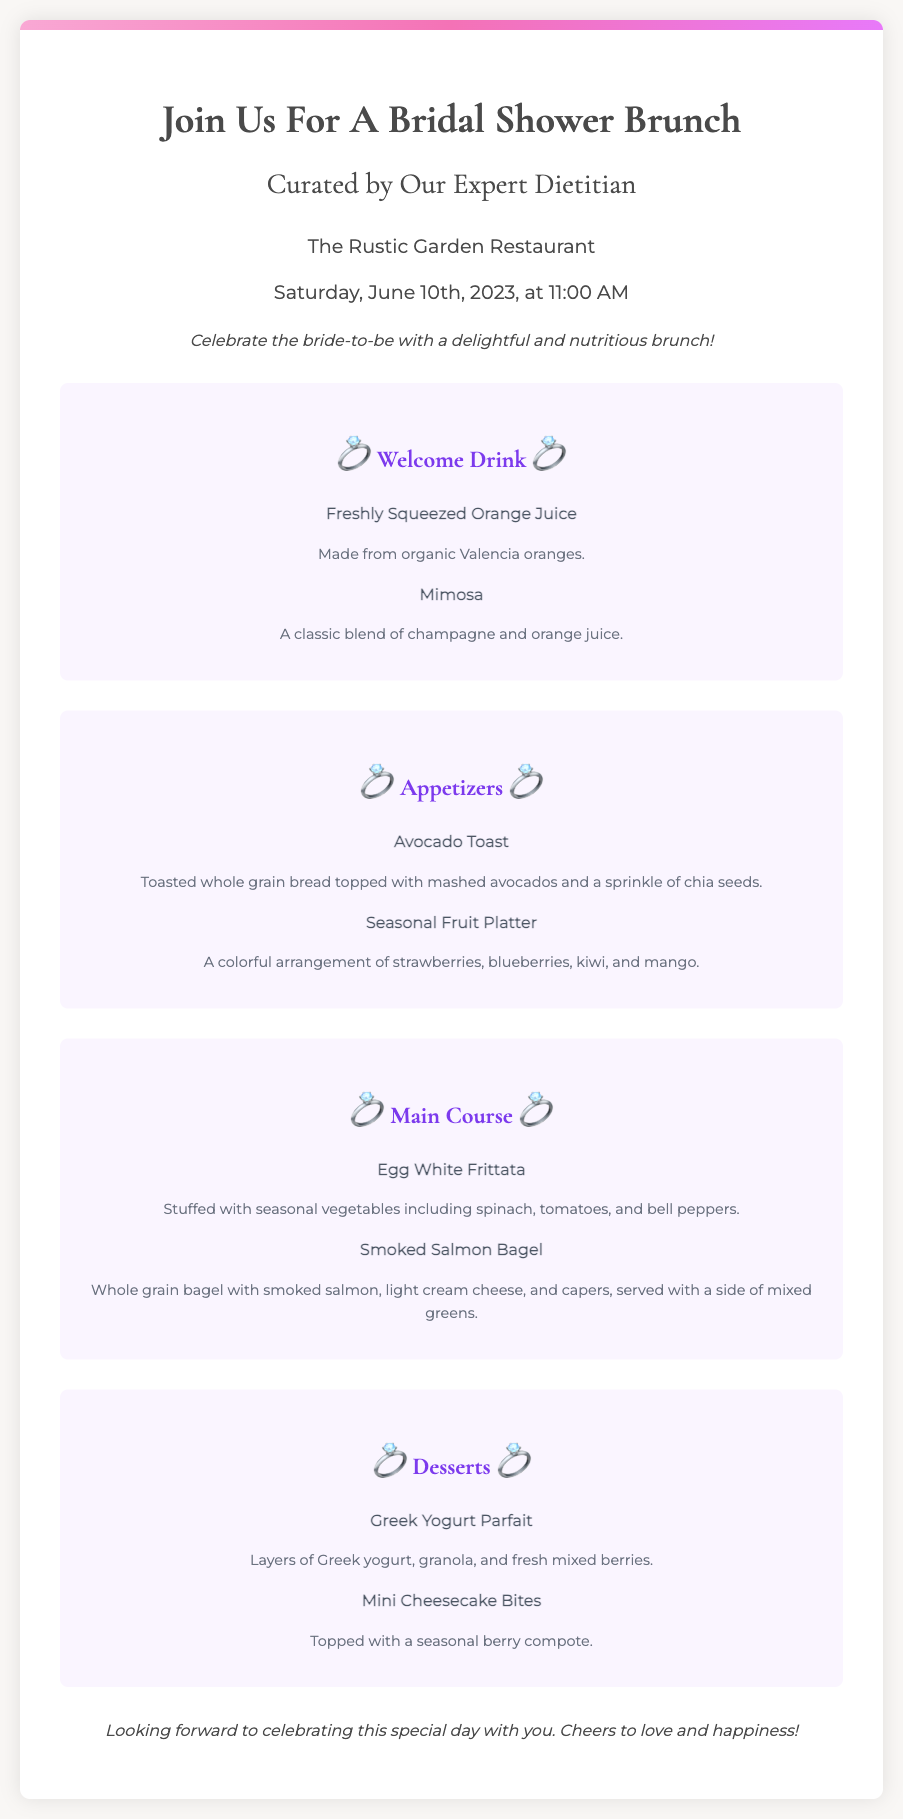What is the date of the Bridal Shower Brunch? The date is explicitly mentioned in the document as "Saturday, June 10th, 2023."
Answer: Saturday, June 10th, 2023 What is the time of the event? The time is provided within the date-time section of the document, stating "at 11:00 AM."
Answer: 11:00 AM Who curated the menu for the brunch? It is specified in the title that the menu is "Curated by Our Expert Dietitian."
Answer: Our Expert Dietitian What is one of the welcome drinks listed? The document lists specific welcome drinks, including "Freshly Squeezed Orange Juice."
Answer: Freshly Squeezed Orange Juice What type of bread is used for the Avocado Toast? The description of the Avocado Toast states it is made with "toasted whole grain bread."
Answer: Whole grain bread How many menu sections are there in the document? The document outlines the menu in four distinct sections: Welcome Drink, Appetizers, Main Course, and Desserts.
Answer: Four What is included in the Seasonal Fruit Platter? The platter is described to contain "strawberries, blueberries, kiwi, and mango."
Answer: Strawberries, blueberries, kiwi, and mango What dessert features Greek yogurt? The Greek Yogurt Parfait is mentioned under the desserts section in the document.
Answer: Greek Yogurt Parfait What does the closing statement express? The closing expresses anticipation and positivity about the event, stating, "Looking forward to celebrating this special day with you."
Answer: Celebrating this special day with you 